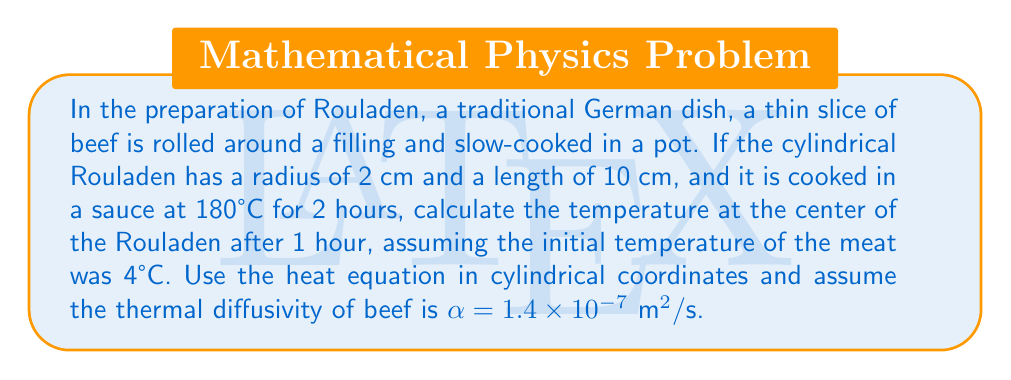Could you help me with this problem? To solve this problem, we'll use the heat equation in cylindrical coordinates:

$$\frac{\partial T}{\partial t} = \alpha \left(\frac{\partial^2 T}{\partial r^2} + \frac{1}{r}\frac{\partial T}{\partial r} + \frac{\partial^2 T}{\partial z^2}\right)$$

Given the symmetry of the problem, we can assume that the temperature only depends on the radial coordinate $r$ and time $t$. This simplifies our equation to:

$$\frac{\partial T}{\partial t} = \alpha \left(\frac{\partial^2 T}{\partial r^2} + \frac{1}{r}\frac{\partial T}{\partial r}\right)$$

The boundary and initial conditions are:
1. $T(r,0) = 4°C$ for $0 \leq r \leq 2$ cm (initial temperature)
2. $T(2,t) = 180°C$ for $t > 0$ (surface temperature)

The solution to this equation for a cylinder initially at a uniform temperature and suddenly exposed to a different temperature at its surface is:

$$T(r,t) = T_s + (T_0 - T_s)\sum_{n=1}^{\infty}\frac{2}{a\alpha_n J_1(a\alpha_n)}J_0(r\alpha_n)e^{-\alpha\alpha_n^2t}$$

Where:
- $T_s$ is the surface temperature (180°C)
- $T_0$ is the initial temperature (4°C)
- $a$ is the radius of the cylinder (2 cm = 0.02 m)
- $J_0$ and $J_1$ are Bessel functions of the first kind
- $\alpha_n$ are the positive roots of $J_0(a\alpha_n) = 0$

To find the temperature at the center after 1 hour, we need to evaluate this at $r=0$ and $t=3600$ s:

$$T(0,3600) = 180 + (4 - 180)\sum_{n=1}^{\infty}\frac{2}{0.02\alpha_n J_1(0.02\alpha_n)}e^{-1.4 \times 10^{-7}\alpha_n^2 3600}$$

Using numerical methods to evaluate this series (as it converges quickly, we can use the first few terms), we find:

$$T(0,3600) \approx 132.5°C$$
Answer: 132.5°C 